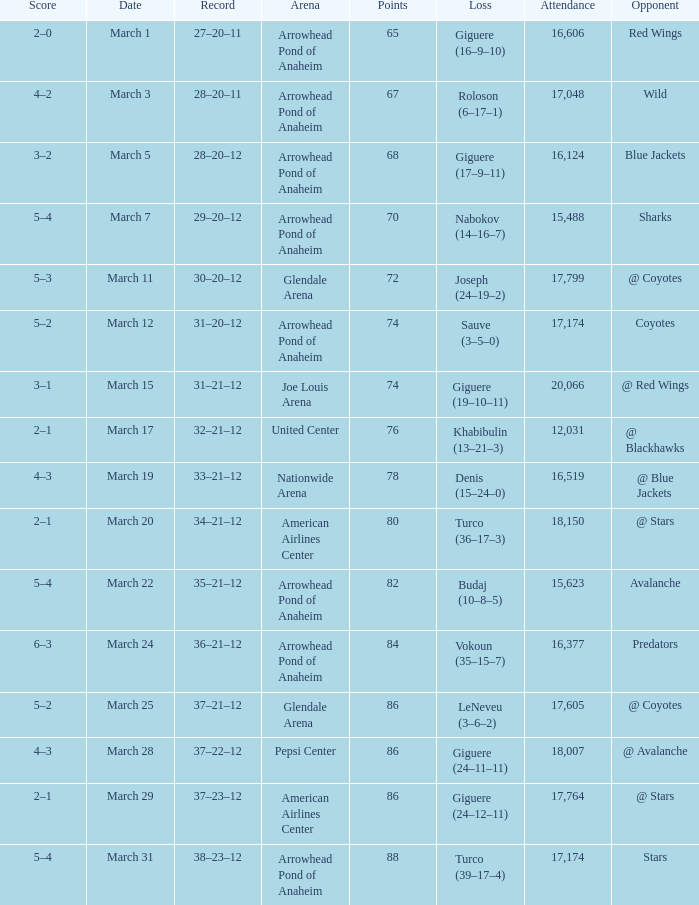What is the Record of the game with an Attendance of more than 16,124 and a Score of 6–3? 36–21–12. 